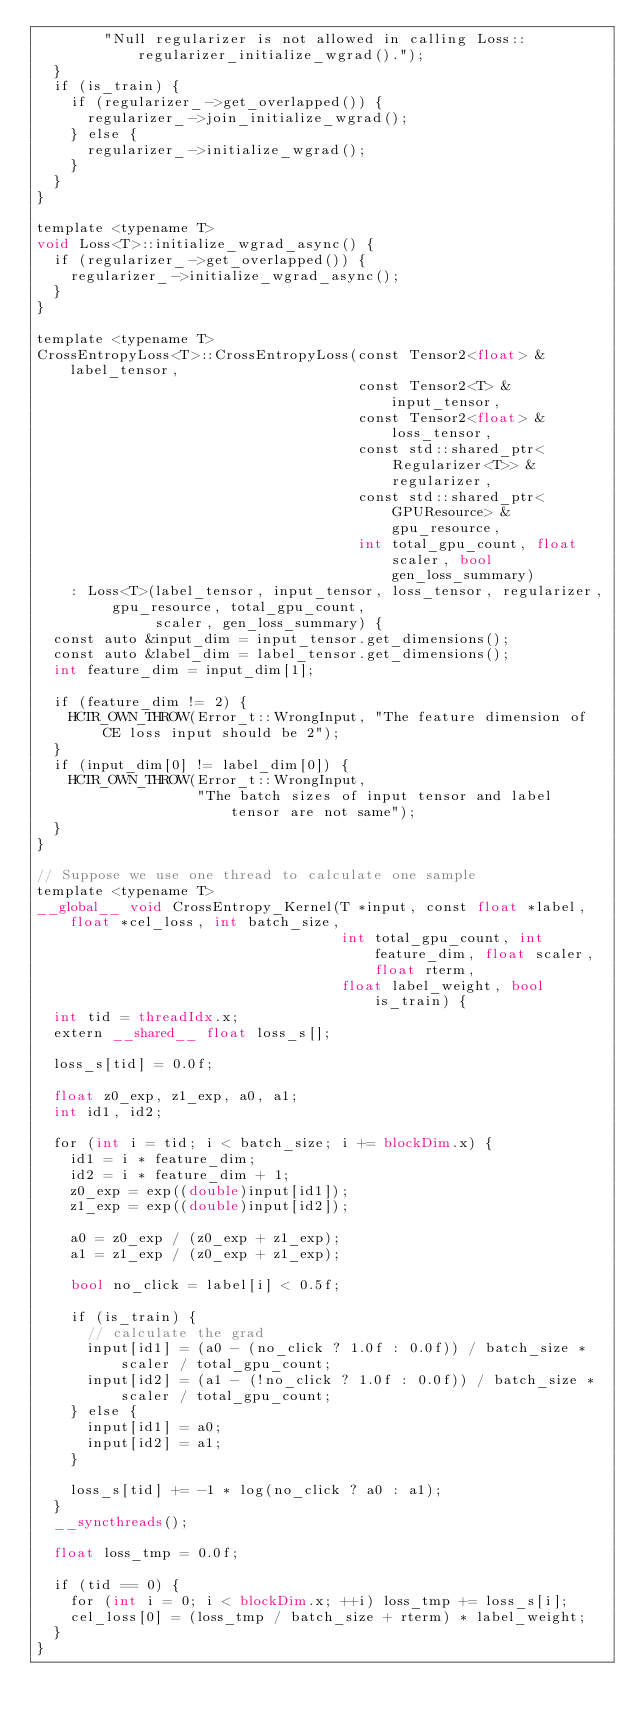<code> <loc_0><loc_0><loc_500><loc_500><_Cuda_>        "Null regularizer is not allowed in calling Loss::regularizer_initialize_wgrad().");
  }
  if (is_train) {
    if (regularizer_->get_overlapped()) {
      regularizer_->join_initialize_wgrad();
    } else {
      regularizer_->initialize_wgrad();
    }
  }
}

template <typename T>
void Loss<T>::initialize_wgrad_async() {
  if (regularizer_->get_overlapped()) {
    regularizer_->initialize_wgrad_async();
  }
}

template <typename T>
CrossEntropyLoss<T>::CrossEntropyLoss(const Tensor2<float> &label_tensor,
                                      const Tensor2<T> &input_tensor,
                                      const Tensor2<float> &loss_tensor,
                                      const std::shared_ptr<Regularizer<T>> &regularizer,
                                      const std::shared_ptr<GPUResource> &gpu_resource,
                                      int total_gpu_count, float scaler, bool gen_loss_summary)
    : Loss<T>(label_tensor, input_tensor, loss_tensor, regularizer, gpu_resource, total_gpu_count,
              scaler, gen_loss_summary) {
  const auto &input_dim = input_tensor.get_dimensions();
  const auto &label_dim = label_tensor.get_dimensions();
  int feature_dim = input_dim[1];

  if (feature_dim != 2) {
    HCTR_OWN_THROW(Error_t::WrongInput, "The feature dimension of CE loss input should be 2");
  }
  if (input_dim[0] != label_dim[0]) {
    HCTR_OWN_THROW(Error_t::WrongInput,
                   "The batch sizes of input tensor and label tensor are not same");
  }
}

// Suppose we use one thread to calculate one sample
template <typename T>
__global__ void CrossEntropy_Kernel(T *input, const float *label, float *cel_loss, int batch_size,
                                    int total_gpu_count, int feature_dim, float scaler, float rterm,
                                    float label_weight, bool is_train) {
  int tid = threadIdx.x;
  extern __shared__ float loss_s[];

  loss_s[tid] = 0.0f;

  float z0_exp, z1_exp, a0, a1;
  int id1, id2;

  for (int i = tid; i < batch_size; i += blockDim.x) {
    id1 = i * feature_dim;
    id2 = i * feature_dim + 1;
    z0_exp = exp((double)input[id1]);
    z1_exp = exp((double)input[id2]);

    a0 = z0_exp / (z0_exp + z1_exp);
    a1 = z1_exp / (z0_exp + z1_exp);

    bool no_click = label[i] < 0.5f;

    if (is_train) {
      // calculate the grad
      input[id1] = (a0 - (no_click ? 1.0f : 0.0f)) / batch_size * scaler / total_gpu_count;
      input[id2] = (a1 - (!no_click ? 1.0f : 0.0f)) / batch_size * scaler / total_gpu_count;
    } else {
      input[id1] = a0;
      input[id2] = a1;
    }

    loss_s[tid] += -1 * log(no_click ? a0 : a1);
  }
  __syncthreads();

  float loss_tmp = 0.0f;

  if (tid == 0) {
    for (int i = 0; i < blockDim.x; ++i) loss_tmp += loss_s[i];
    cel_loss[0] = (loss_tmp / batch_size + rterm) * label_weight;
  }
}
</code> 